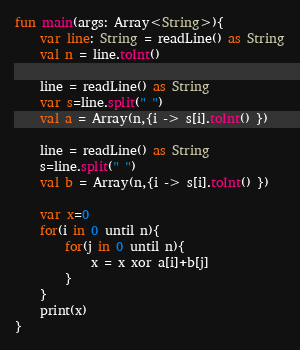<code> <loc_0><loc_0><loc_500><loc_500><_Kotlin_>fun main(args: Array<String>){
    var line: String = readLine() as String
    val n = line.toInt()

    line = readLine() as String
    var s=line.split(" ")
    val a = Array(n,{i -> s[i].toInt() })

    line = readLine() as String
    s=line.split(" ")
    val b = Array(n,{i -> s[i].toInt() })

    var x=0
    for(i in 0 until n){
        for(j in 0 until n){
            x = x xor a[i]+b[j]
        }
    }
    print(x)
}</code> 